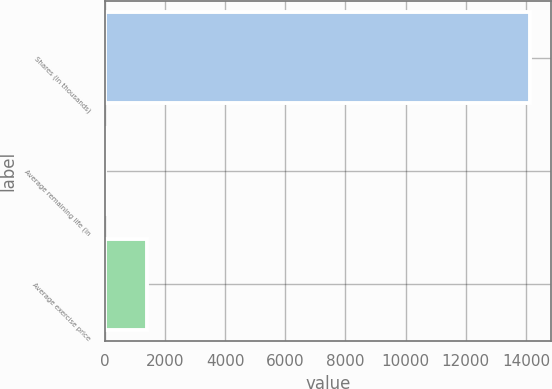Convert chart. <chart><loc_0><loc_0><loc_500><loc_500><bar_chart><fcel>Shares (in thousands)<fcel>Average remaining life (in<fcel>Average exercise price<nl><fcel>14134<fcel>8.1<fcel>1420.69<nl></chart> 